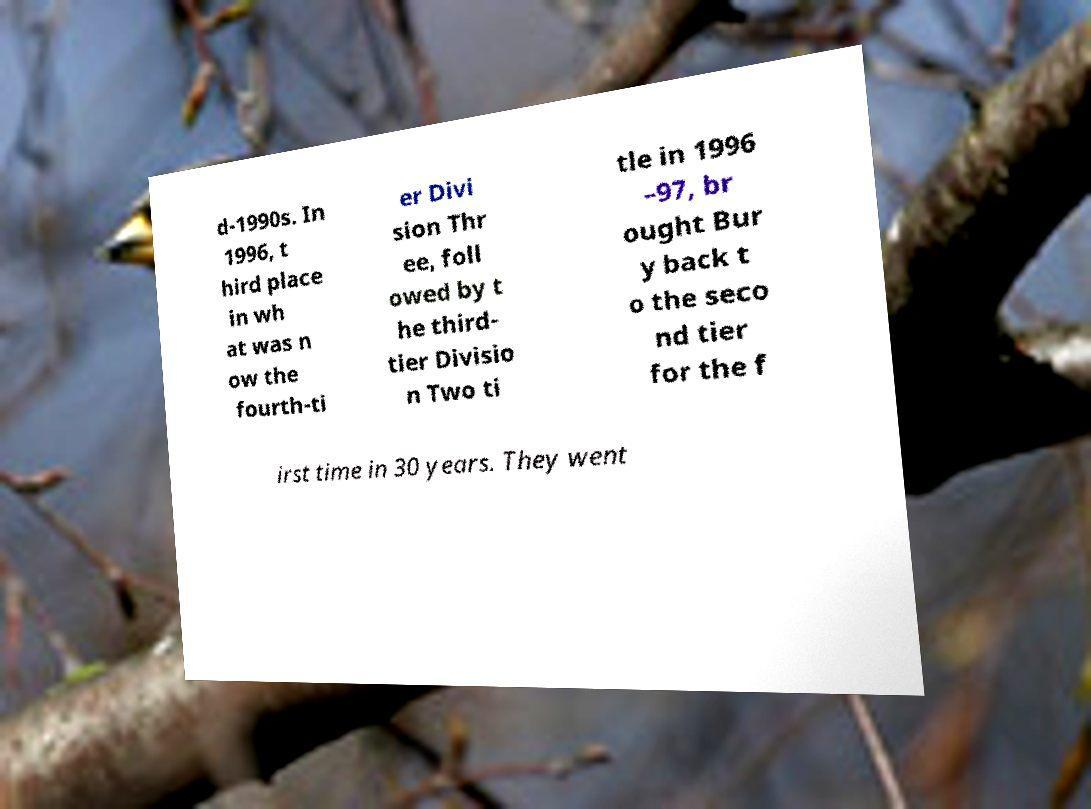What messages or text are displayed in this image? I need them in a readable, typed format. d-1990s. In 1996, t hird place in wh at was n ow the fourth-ti er Divi sion Thr ee, foll owed by t he third- tier Divisio n Two ti tle in 1996 –97, br ought Bur y back t o the seco nd tier for the f irst time in 30 years. They went 